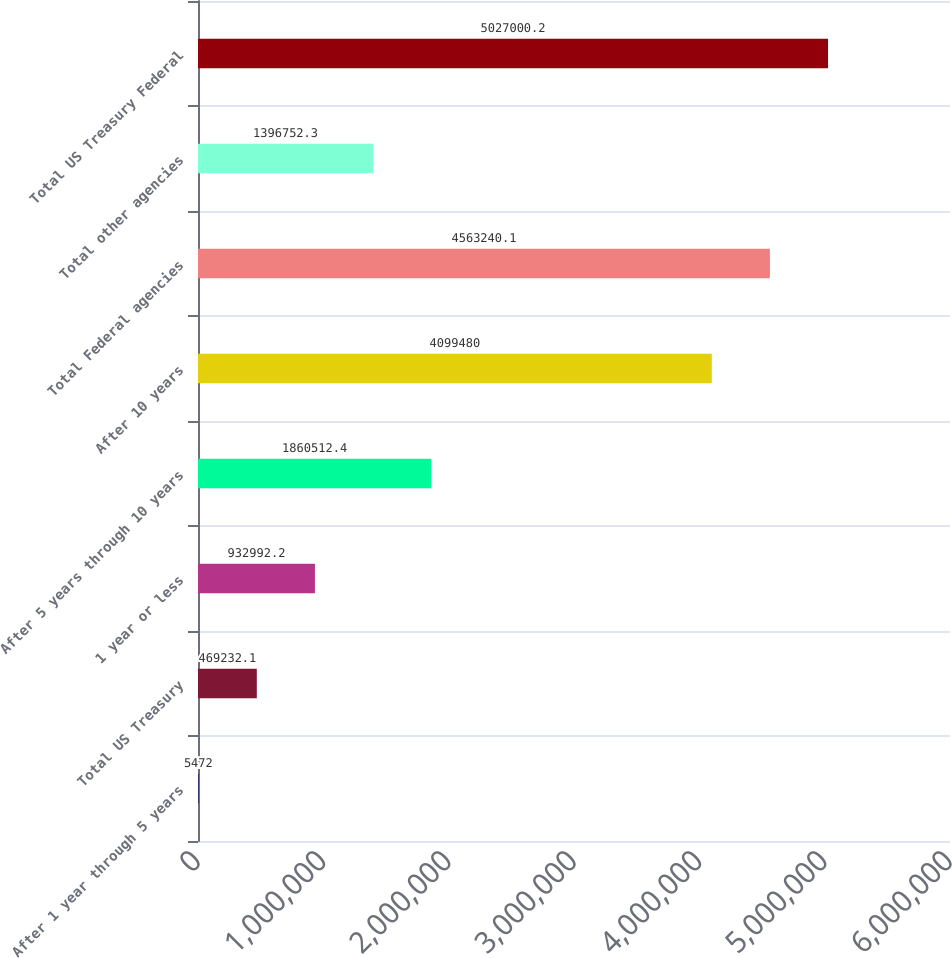Convert chart. <chart><loc_0><loc_0><loc_500><loc_500><bar_chart><fcel>After 1 year through 5 years<fcel>Total US Treasury<fcel>1 year or less<fcel>After 5 years through 10 years<fcel>After 10 years<fcel>Total Federal agencies<fcel>Total other agencies<fcel>Total US Treasury Federal<nl><fcel>5472<fcel>469232<fcel>932992<fcel>1.86051e+06<fcel>4.09948e+06<fcel>4.56324e+06<fcel>1.39675e+06<fcel>5.027e+06<nl></chart> 